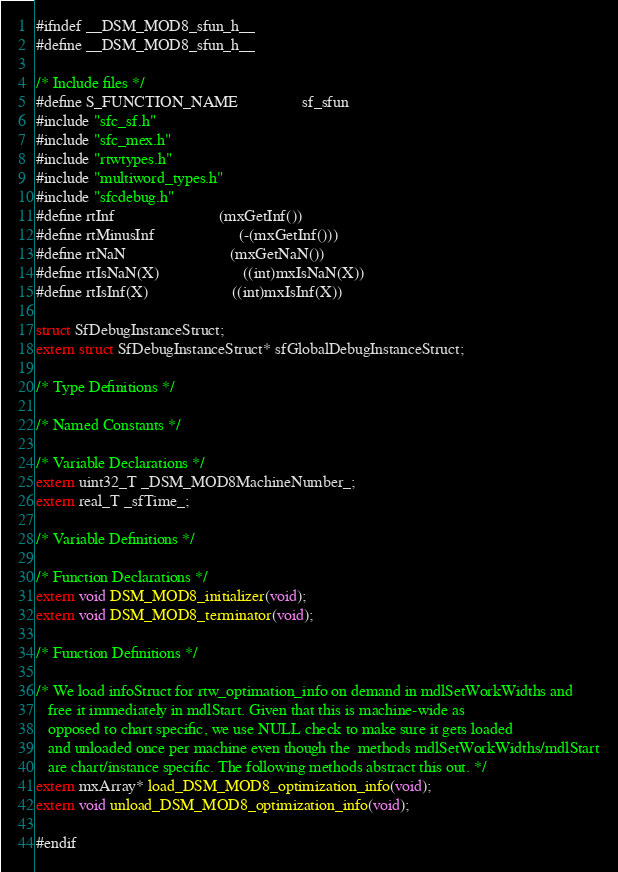Convert code to text. <code><loc_0><loc_0><loc_500><loc_500><_C_>#ifndef __DSM_MOD8_sfun_h__
#define __DSM_MOD8_sfun_h__

/* Include files */
#define S_FUNCTION_NAME                sf_sfun
#include "sfc_sf.h"
#include "sfc_mex.h"
#include "rtwtypes.h"
#include "multiword_types.h"
#include "sfcdebug.h"
#define rtInf                          (mxGetInf())
#define rtMinusInf                     (-(mxGetInf()))
#define rtNaN                          (mxGetNaN())
#define rtIsNaN(X)                     ((int)mxIsNaN(X))
#define rtIsInf(X)                     ((int)mxIsInf(X))

struct SfDebugInstanceStruct;
extern struct SfDebugInstanceStruct* sfGlobalDebugInstanceStruct;

/* Type Definitions */

/* Named Constants */

/* Variable Declarations */
extern uint32_T _DSM_MOD8MachineNumber_;
extern real_T _sfTime_;

/* Variable Definitions */

/* Function Declarations */
extern void DSM_MOD8_initializer(void);
extern void DSM_MOD8_terminator(void);

/* Function Definitions */

/* We load infoStruct for rtw_optimation_info on demand in mdlSetWorkWidths and
   free it immediately in mdlStart. Given that this is machine-wide as
   opposed to chart specific, we use NULL check to make sure it gets loaded
   and unloaded once per machine even though the  methods mdlSetWorkWidths/mdlStart
   are chart/instance specific. The following methods abstract this out. */
extern mxArray* load_DSM_MOD8_optimization_info(void);
extern void unload_DSM_MOD8_optimization_info(void);

#endif
</code> 